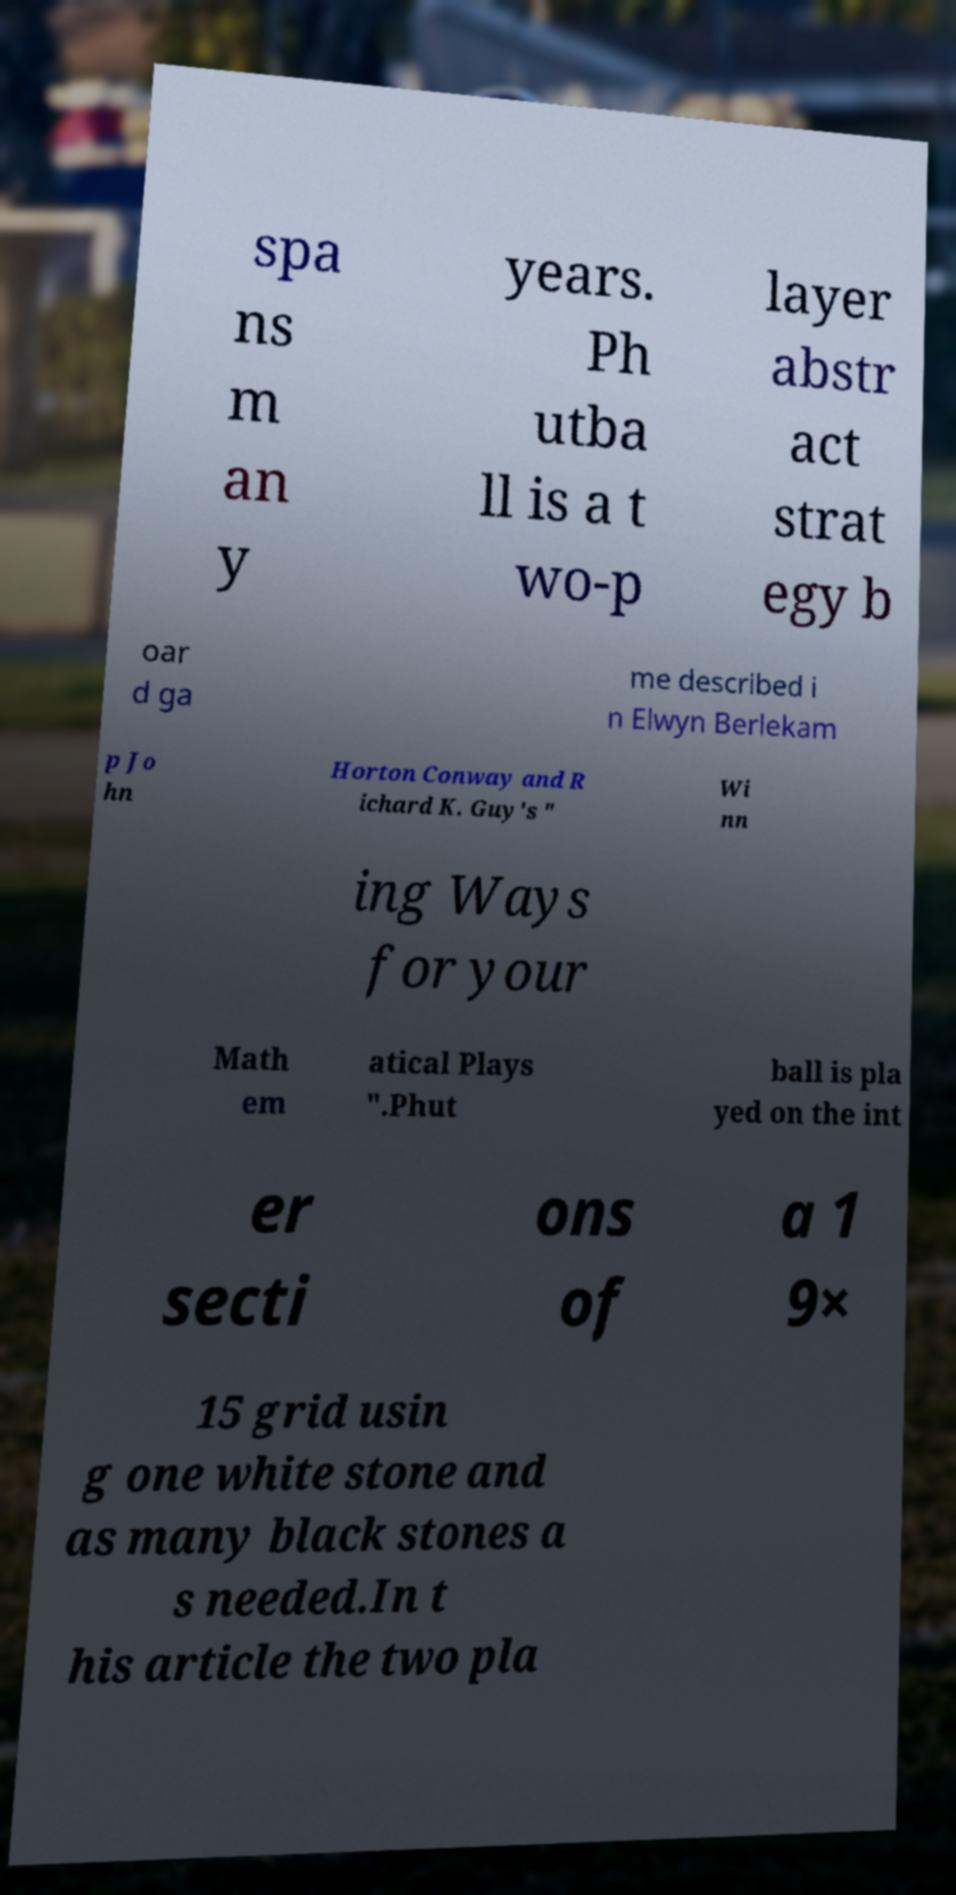For documentation purposes, I need the text within this image transcribed. Could you provide that? spa ns m an y years. Ph utba ll is a t wo-p layer abstr act strat egy b oar d ga me described i n Elwyn Berlekam p Jo hn Horton Conway and R ichard K. Guy's " Wi nn ing Ways for your Math em atical Plays ".Phut ball is pla yed on the int er secti ons of a 1 9× 15 grid usin g one white stone and as many black stones a s needed.In t his article the two pla 